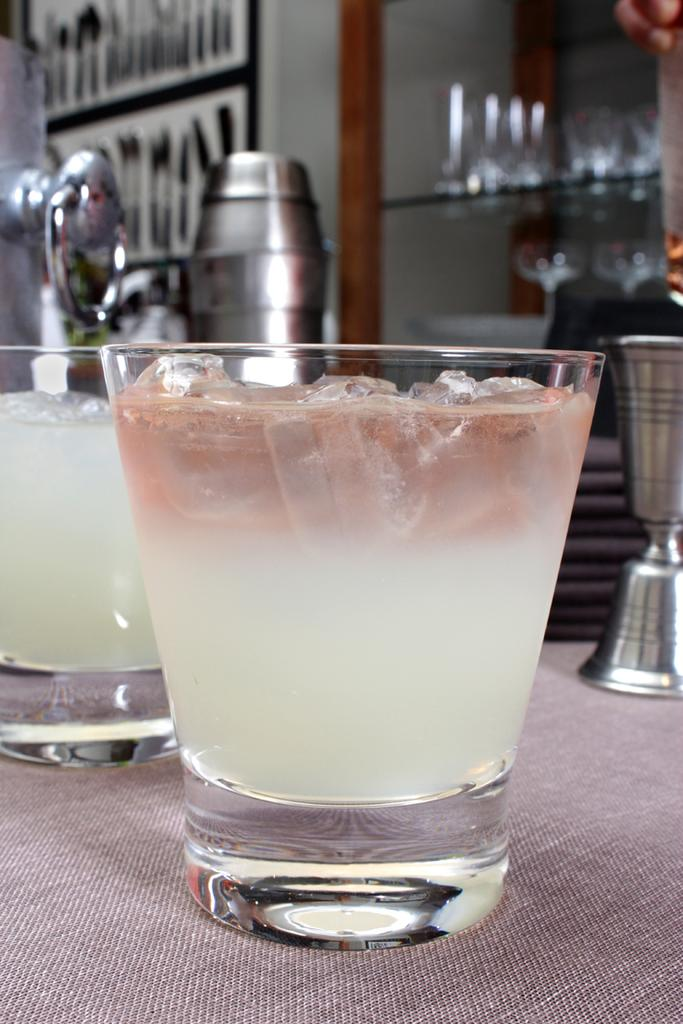How many glasses are present in the image? There are two glasses in the image. What is inside the glasses? The glasses contain liquid and ice cubes. What type of objects can be seen behind the glasses? There are metal objects visible behind the glasses. Where is the table located in the image? There is no table present in the image. What type of iron is visible in the image? There is no iron present in the image. 